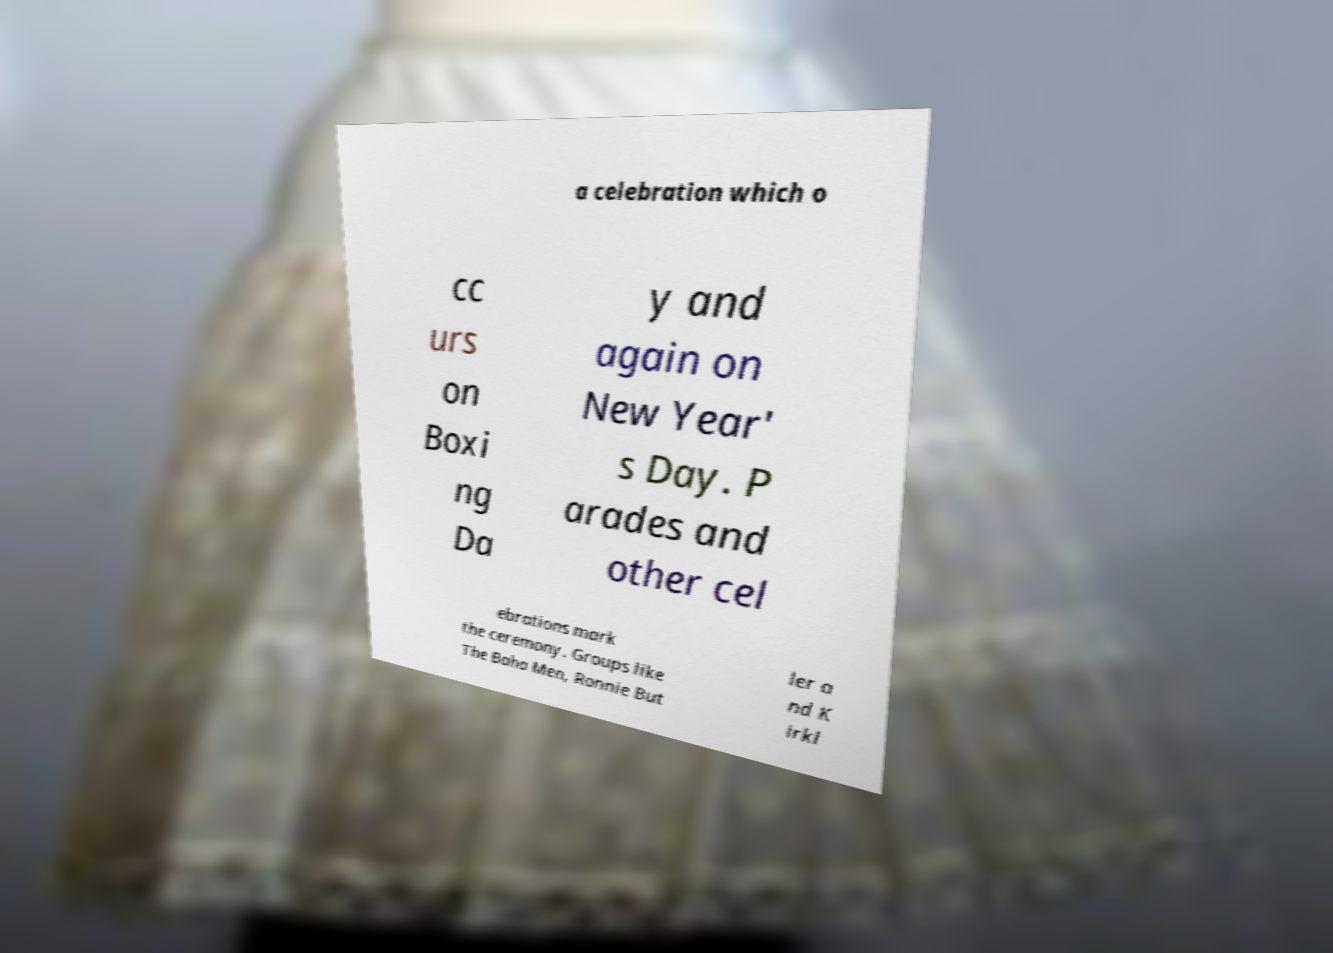What messages or text are displayed in this image? I need them in a readable, typed format. a celebration which o cc urs on Boxi ng Da y and again on New Year' s Day. P arades and other cel ebrations mark the ceremony. Groups like The Baha Men, Ronnie But ler a nd K irkl 